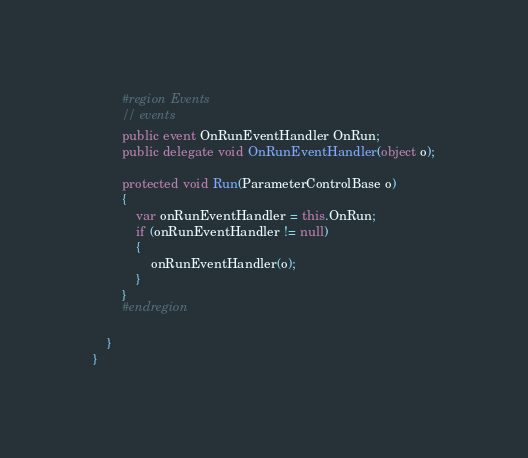Convert code to text. <code><loc_0><loc_0><loc_500><loc_500><_C#_>        #region Events
        // events
        public event OnRunEventHandler OnRun;
        public delegate void OnRunEventHandler(object o);

        protected void Run(ParameterControlBase o)
        {
            var onRunEventHandler = this.OnRun;
            if (onRunEventHandler != null)
            {
                onRunEventHandler(o);
            }
        }
        #endregion

    }
}

</code> 